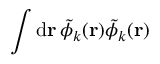<formula> <loc_0><loc_0><loc_500><loc_500>\int d r \, \tilde { \phi } _ { k } ( r ) \tilde { \phi } _ { k } ( r )</formula> 